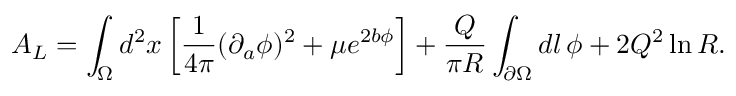Convert formula to latex. <formula><loc_0><loc_0><loc_500><loc_500>A _ { L } = \int _ { \Omega } d ^ { 2 } x \left [ { \frac { 1 } { 4 \pi } } ( \partial _ { a } \phi ) ^ { 2 } + \mu e ^ { 2 b \phi } \right ] + { \frac { Q } { \pi R } } \int _ { \partial \Omega } d l \, \phi + 2 Q ^ { 2 } \ln { R } .</formula> 